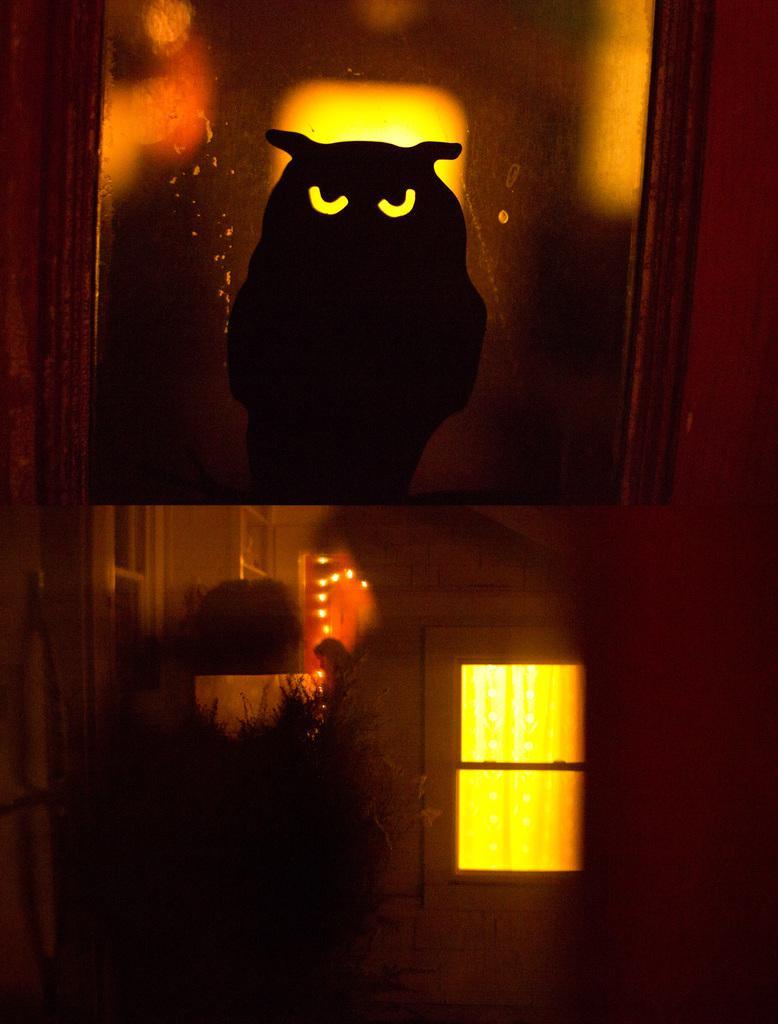Please provide a concise description of this image. In the image there is a wall with window. At the top of the image there is an object which looks like a frame. Inside the frame there is an owl. 